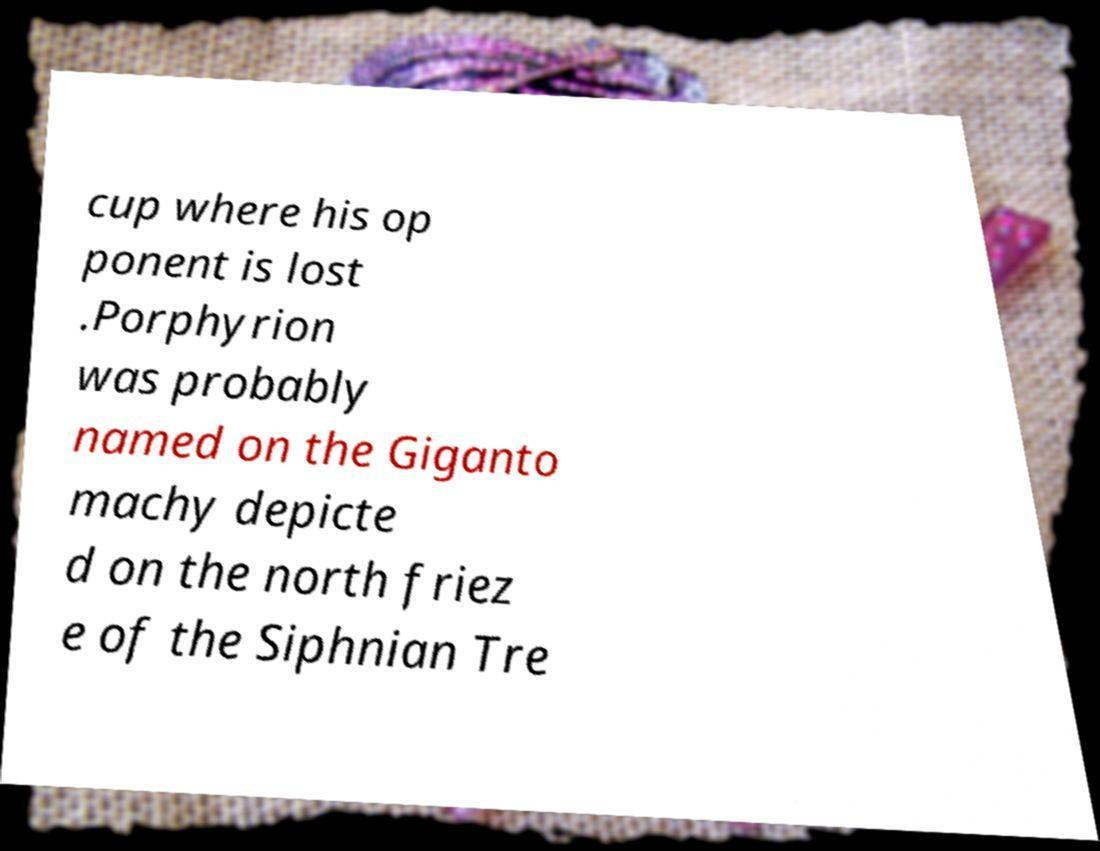Please identify and transcribe the text found in this image. cup where his op ponent is lost .Porphyrion was probably named on the Giganto machy depicte d on the north friez e of the Siphnian Tre 